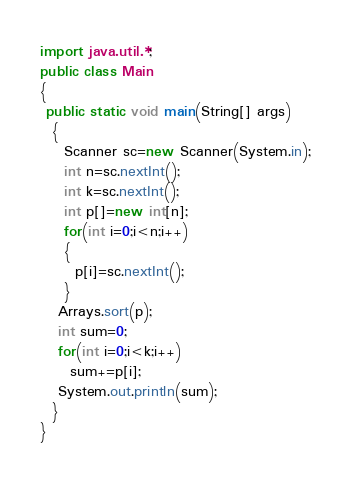<code> <loc_0><loc_0><loc_500><loc_500><_Java_>import java.util.*;
public class Main
{
 public static void main(String[] args)
  {
    Scanner sc=new Scanner(System.in);
    int n=sc.nextInt();
    int k=sc.nextInt();
    int p[]=new int[n];
    for(int i=0;i<n;i++)
    {
      p[i]=sc.nextInt();
    }
   Arrays.sort(p);
   int sum=0;
   for(int i=0;i<k;i++)
     sum+=p[i];
   System.out.println(sum);
  }
}</code> 